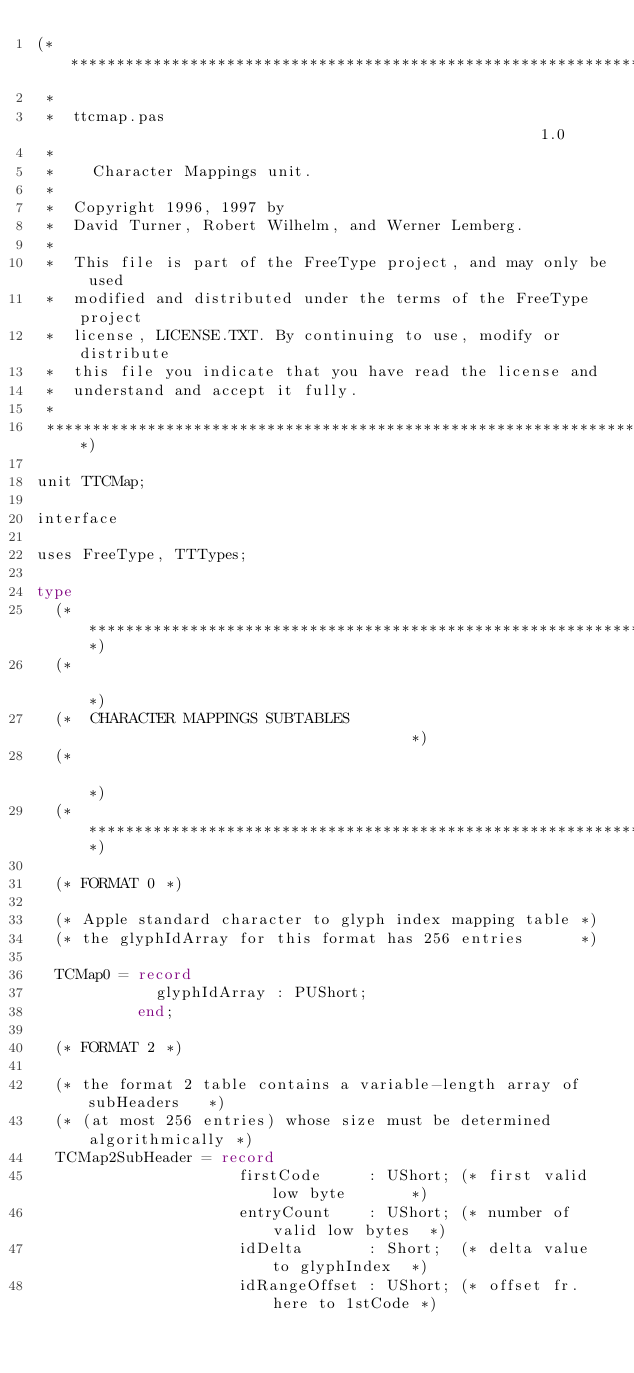Convert code to text. <code><loc_0><loc_0><loc_500><loc_500><_Pascal_>(*******************************************************************
 *
 *  ttcmap.pas                                                   1.0
 *
 *    Character Mappings unit.
 *
 *  Copyright 1996, 1997 by
 *  David Turner, Robert Wilhelm, and Werner Lemberg.
 *
 *  This file is part of the FreeType project, and may only be used
 *  modified and distributed under the terms of the FreeType project
 *  license, LICENSE.TXT. By continuing to use, modify or distribute
 *  this file you indicate that you have read the license and
 *  understand and accept it fully.
 *
 ******************************************************************)

unit TTCMap;

interface

uses FreeType, TTTypes;

type
  (********************************************************************)
  (*                                                                  *)
  (*  CHARACTER MAPPINGS SUBTABLES                                    *)
  (*                                                                  *)
  (********************************************************************)

  (* FORMAT 0 *)

  (* Apple standard character to glyph index mapping table *)
  (* the glyphIdArray for this format has 256 entries      *)

  TCMap0 = record
             glyphIdArray : PUShort;
           end;

  (* FORMAT 2 *)

  (* the format 2 table contains a variable-length array of subHeaders   *)
  (* (at most 256 entries) whose size must be determined algorithmically *)
  TCMap2SubHeader = record
                      firstCode     : UShort; (* first valid low byte       *)
                      entryCount    : UShort; (* number of valid low bytes  *)
                      idDelta       : Short;  (* delta value to glyphIndex  *)
                      idRangeOffset : UShort; (* offset fr. here to 1stCode *)</code> 